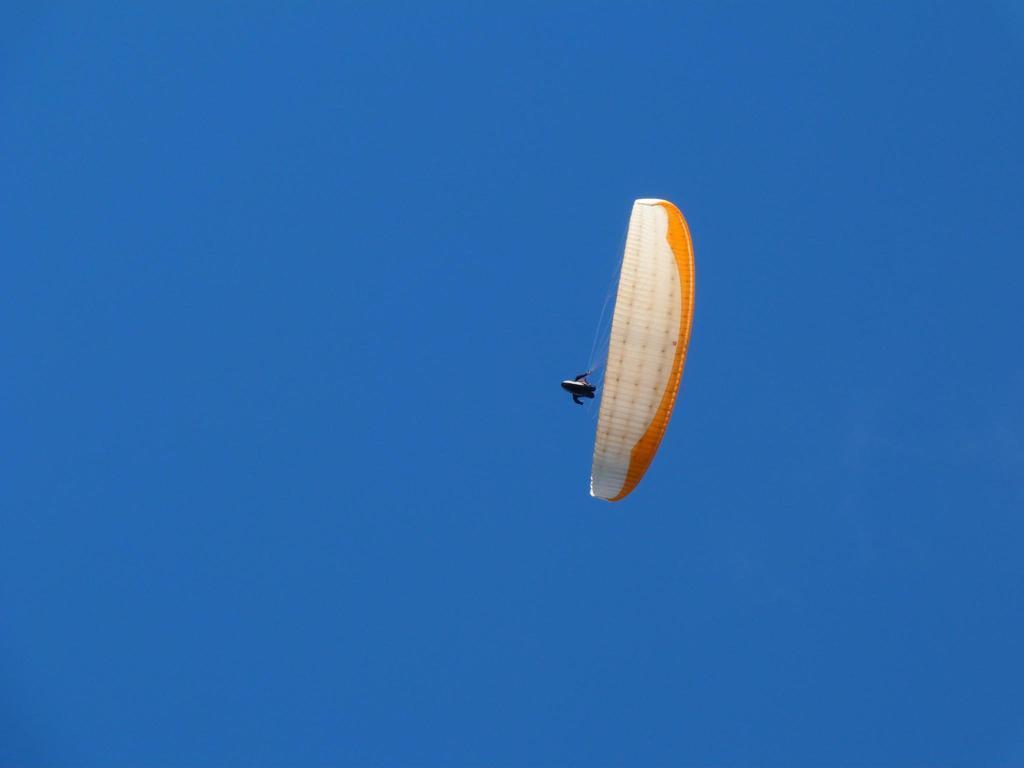Can you describe this image briefly? In this image we can see a parachute flying in a sky. 